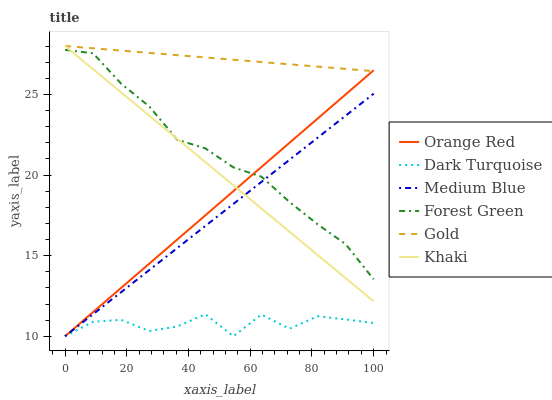Does Dark Turquoise have the minimum area under the curve?
Answer yes or no. Yes. Does Gold have the maximum area under the curve?
Answer yes or no. Yes. Does Gold have the minimum area under the curve?
Answer yes or no. No. Does Dark Turquoise have the maximum area under the curve?
Answer yes or no. No. Is Gold the smoothest?
Answer yes or no. Yes. Is Dark Turquoise the roughest?
Answer yes or no. Yes. Is Dark Turquoise the smoothest?
Answer yes or no. No. Is Gold the roughest?
Answer yes or no. No. Does Gold have the lowest value?
Answer yes or no. No. Does Gold have the highest value?
Answer yes or no. Yes. Does Dark Turquoise have the highest value?
Answer yes or no. No. Is Dark Turquoise less than Forest Green?
Answer yes or no. Yes. Is Gold greater than Forest Green?
Answer yes or no. Yes. Does Forest Green intersect Orange Red?
Answer yes or no. Yes. Is Forest Green less than Orange Red?
Answer yes or no. No. Is Forest Green greater than Orange Red?
Answer yes or no. No. Does Dark Turquoise intersect Forest Green?
Answer yes or no. No. 